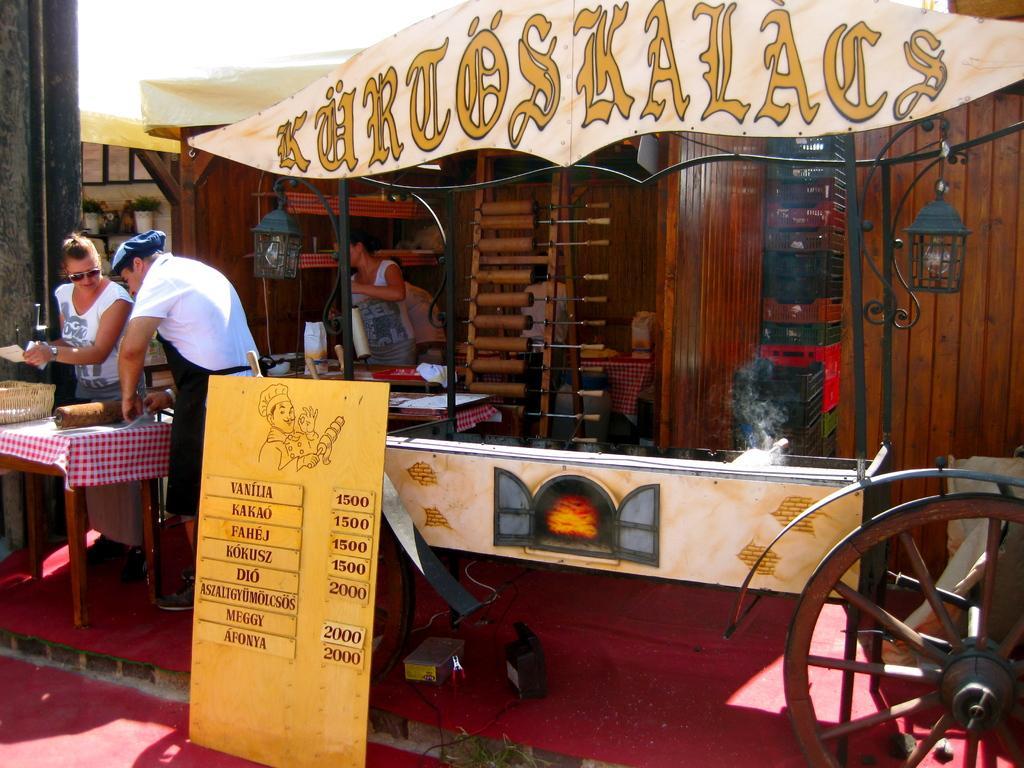Can you describe this image briefly? In this picture i could see a truck with some smoke and a menu board to the left there are two persons standing and preparing food in the background there is a wooden wall and a room in which a person is working. On the floor there is a red carpet. 